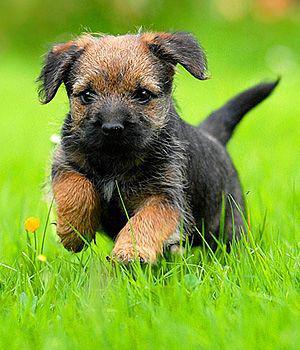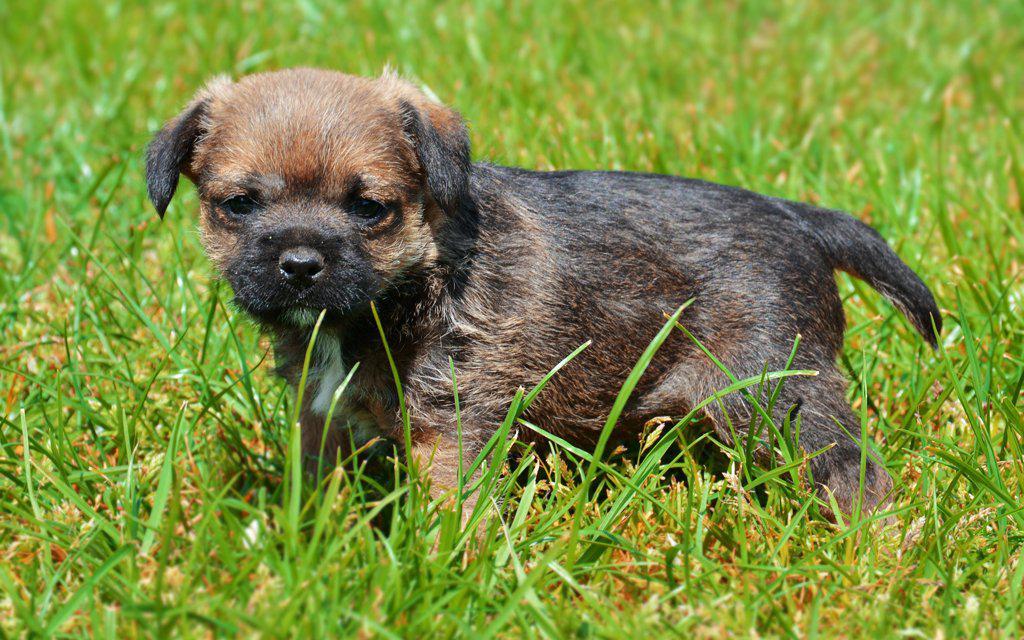The first image is the image on the left, the second image is the image on the right. Given the left and right images, does the statement "A puppy runs in the grass toward the photographer." hold true? Answer yes or no. Yes. The first image is the image on the left, the second image is the image on the right. Assess this claim about the two images: "Both puppies are in green grass with no collar visible.". Correct or not? Answer yes or no. Yes. 